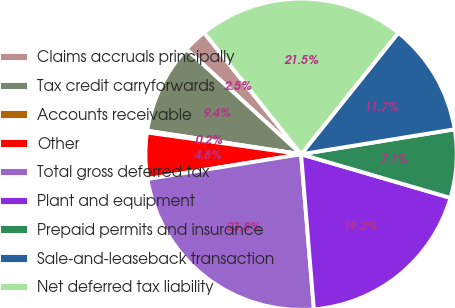Convert chart. <chart><loc_0><loc_0><loc_500><loc_500><pie_chart><fcel>Claims accruals principally<fcel>Tax credit carryforwards<fcel>Accounts receivable<fcel>Other<fcel>Total gross deferred tax<fcel>Plant and equipment<fcel>Prepaid permits and insurance<fcel>Sale-and-leaseback transaction<fcel>Net deferred tax liability<nl><fcel>2.48%<fcel>9.39%<fcel>0.18%<fcel>4.78%<fcel>23.76%<fcel>19.16%<fcel>7.09%<fcel>11.69%<fcel>21.46%<nl></chart> 